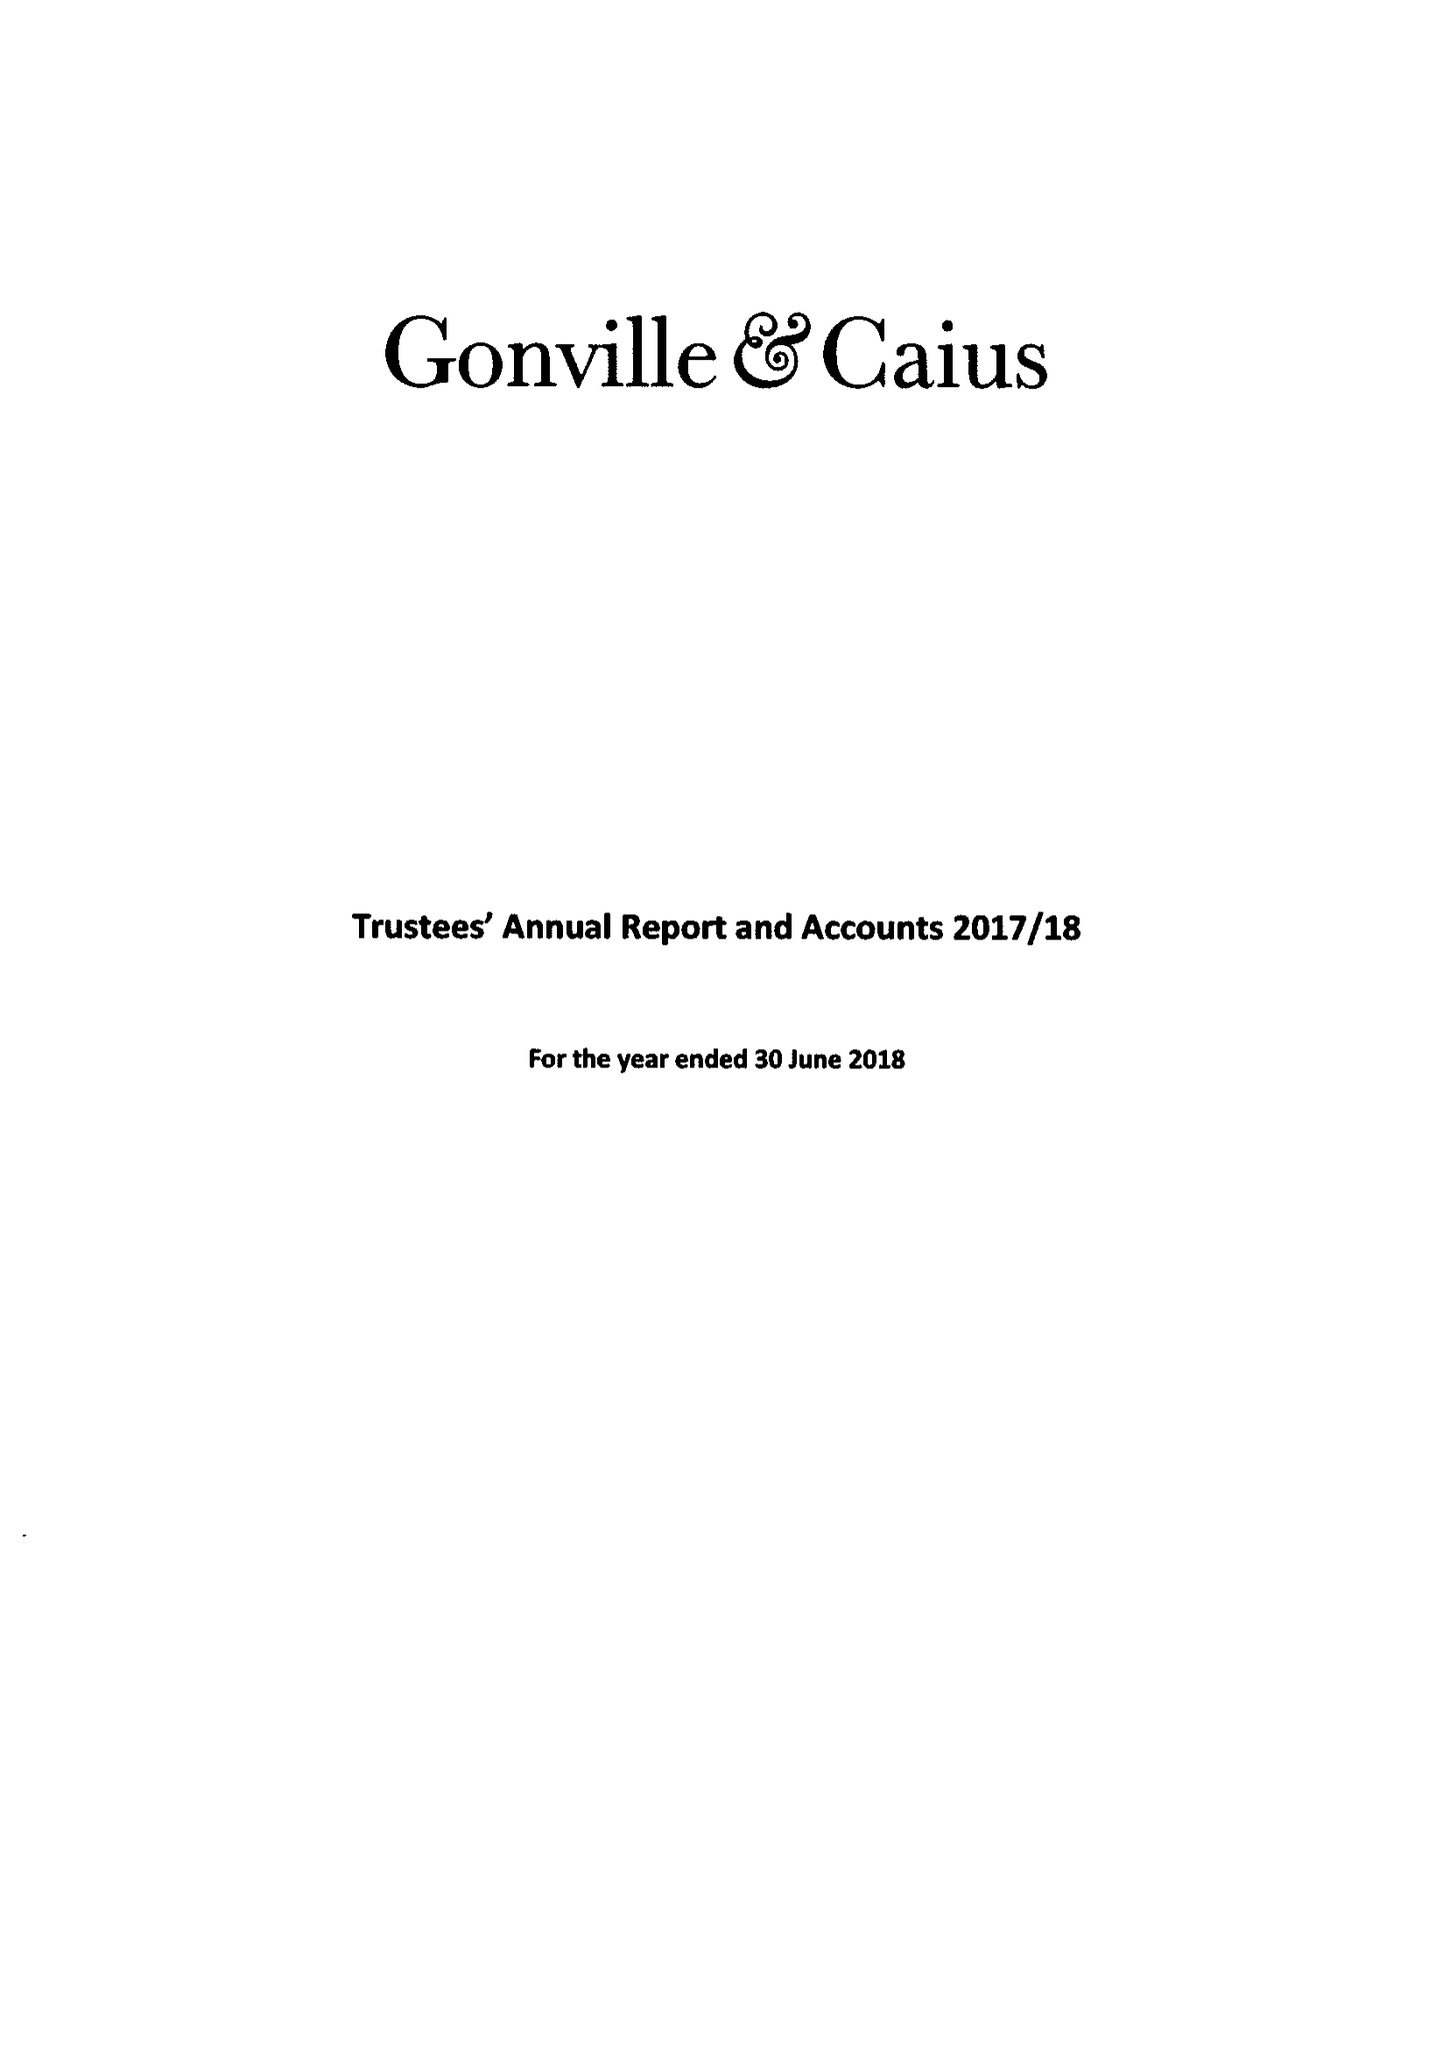What is the value for the address__post_town?
Answer the question using a single word or phrase. CAMBRIDGE 